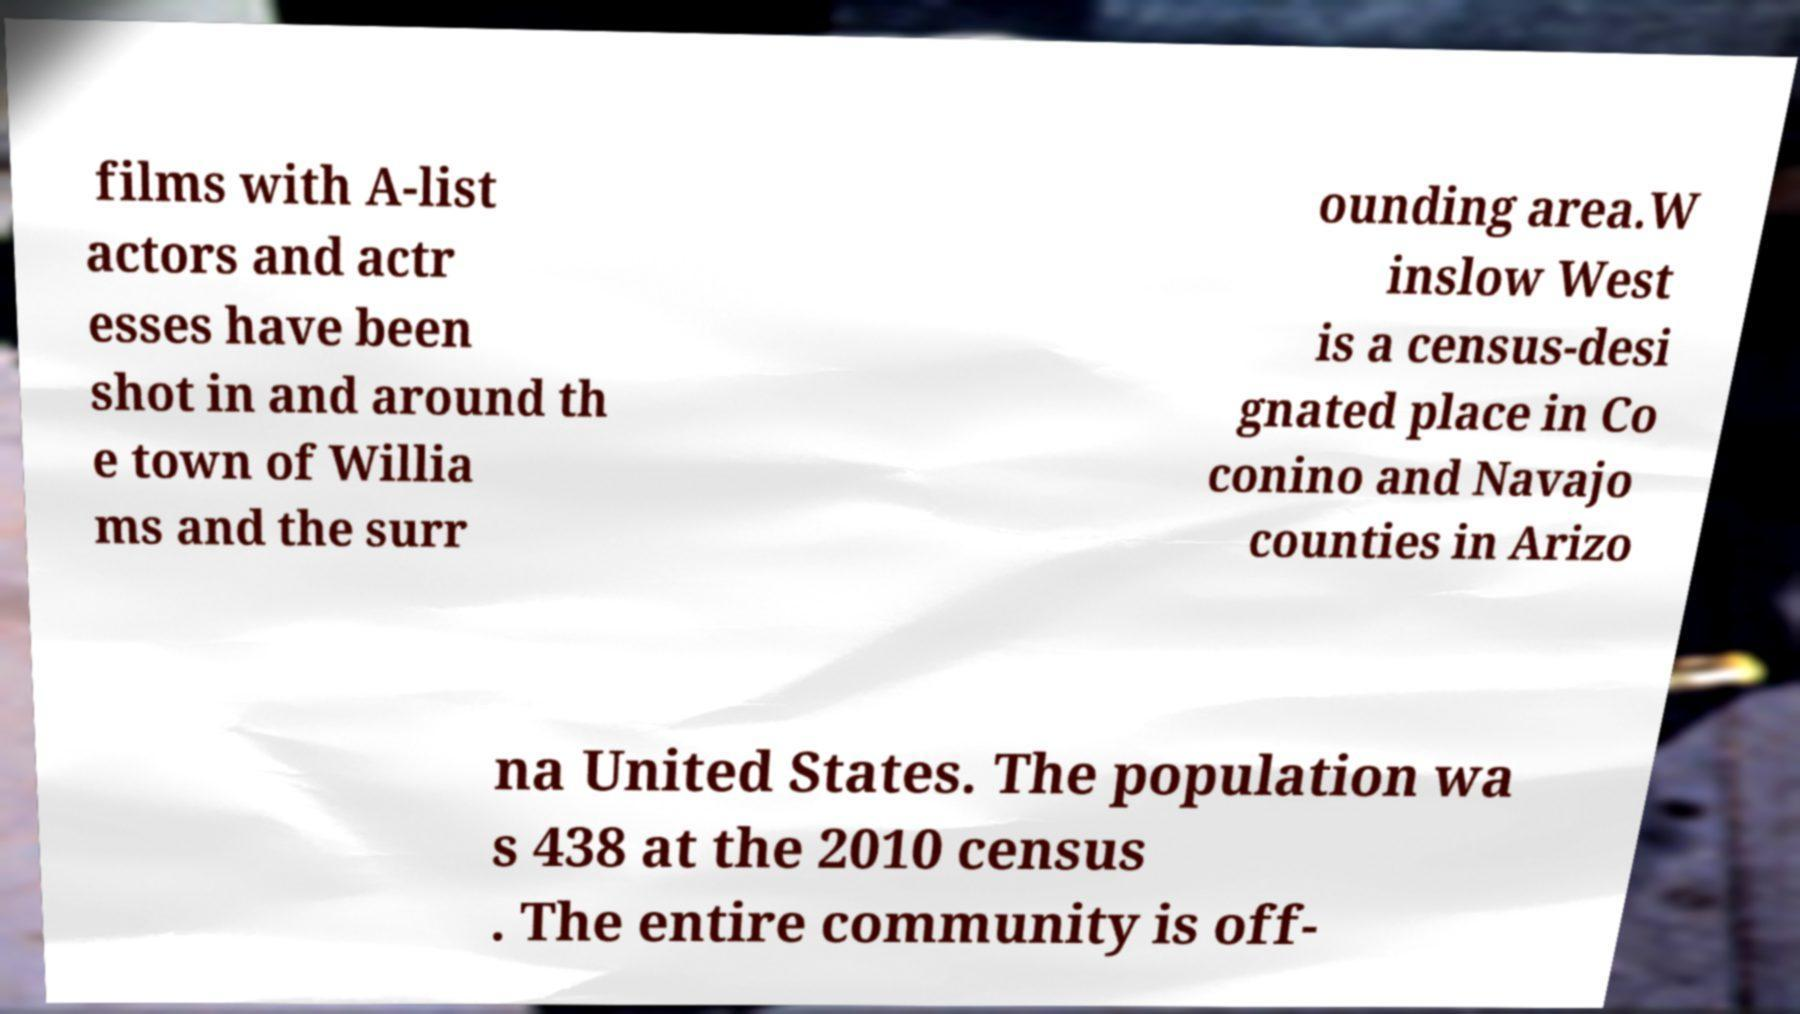Please identify and transcribe the text found in this image. films with A-list actors and actr esses have been shot in and around th e town of Willia ms and the surr ounding area.W inslow West is a census-desi gnated place in Co conino and Navajo counties in Arizo na United States. The population wa s 438 at the 2010 census . The entire community is off- 